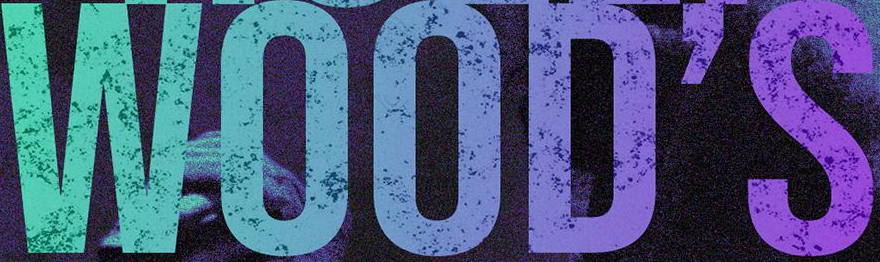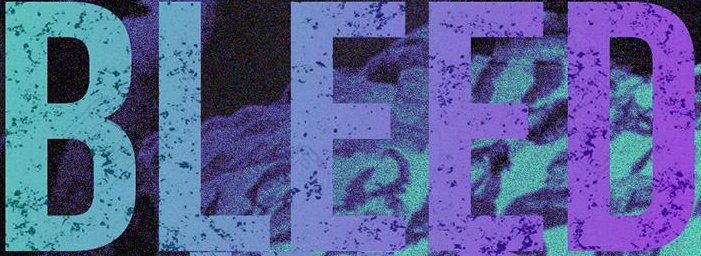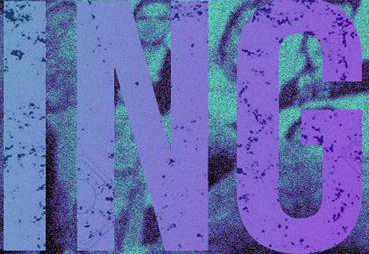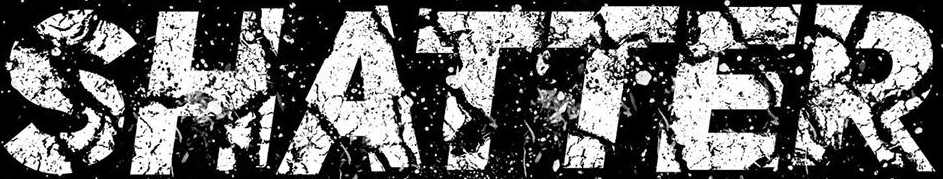Read the text content from these images in order, separated by a semicolon. WOOD'S; BLEED; ING; SHATTER 